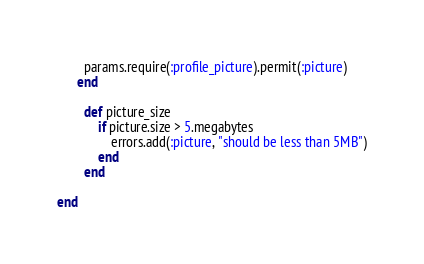<code> <loc_0><loc_0><loc_500><loc_500><_Ruby_>	  	params.require(:profile_picture).permit(:picture)
	  end

		def picture_size
			if picture.size > 5.megabytes
				errors.add(:picture, "should be less than 5MB")
			end
		end

end
</code> 